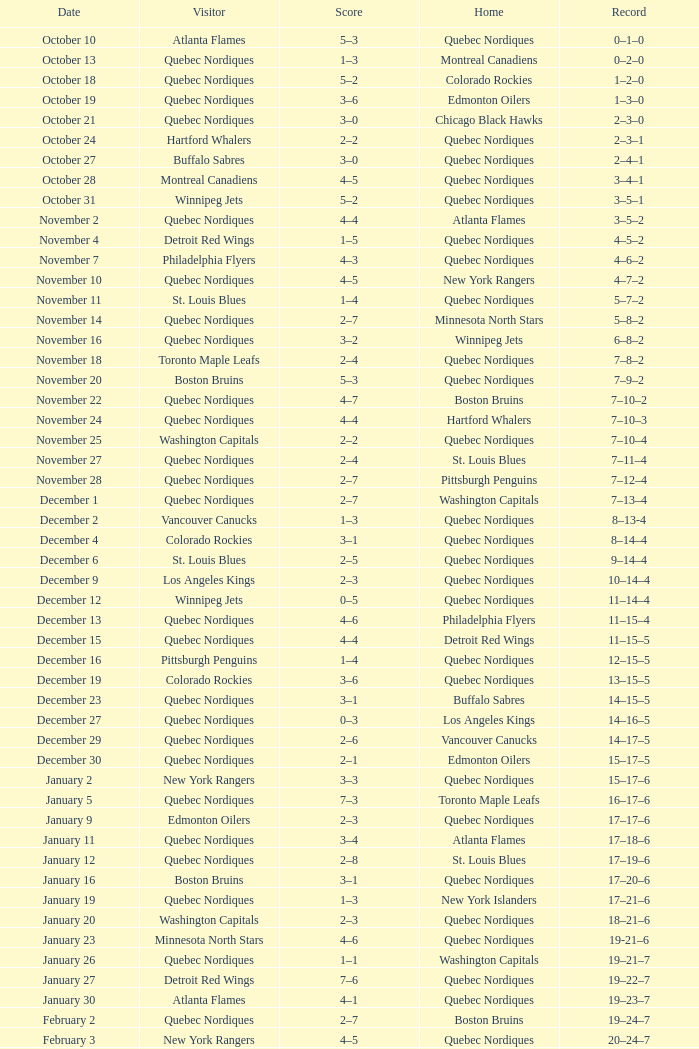Which domicile is dated april 1? Quebec Nordiques. 